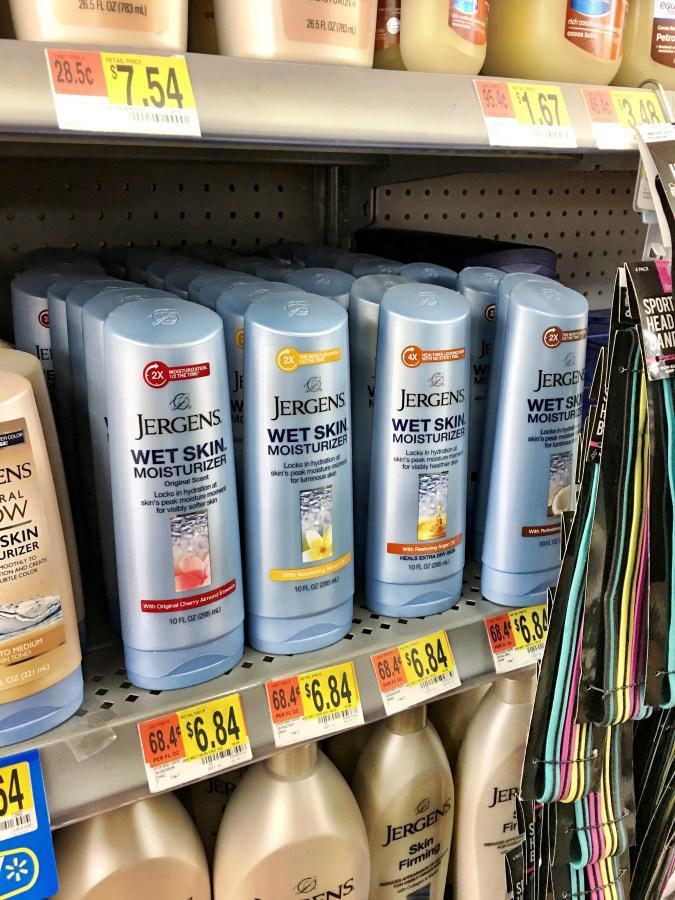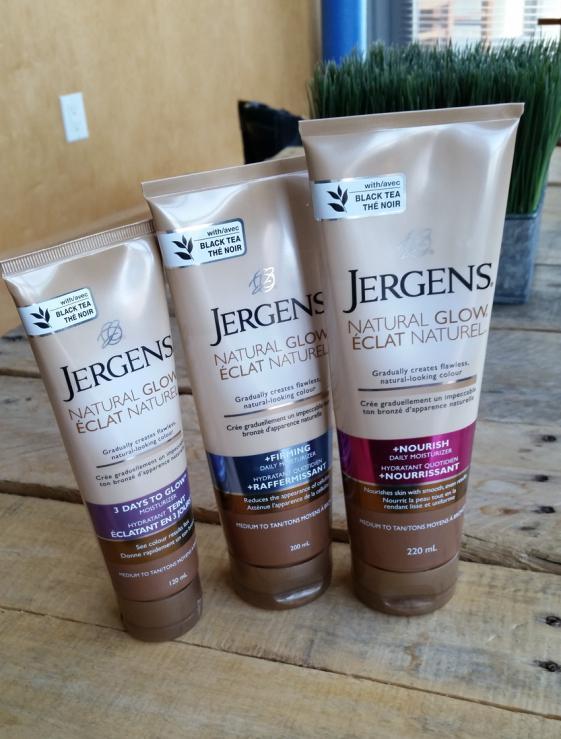The first image is the image on the left, the second image is the image on the right. Evaluate the accuracy of this statement regarding the images: "In at least one image there is a row of three of the same brand moisturizer.". Is it true? Answer yes or no. Yes. The first image is the image on the left, the second image is the image on the right. For the images displayed, is the sentence "Some items are on store shelves." factually correct? Answer yes or no. Yes. 